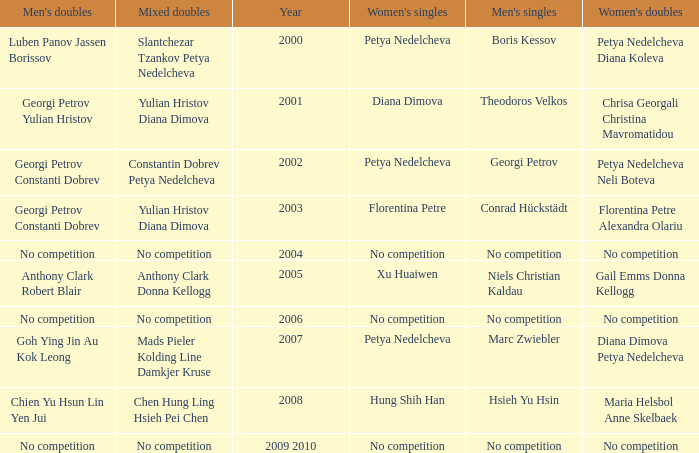In what year was there no competition for women? 2004, 2006, 2009 2010. 